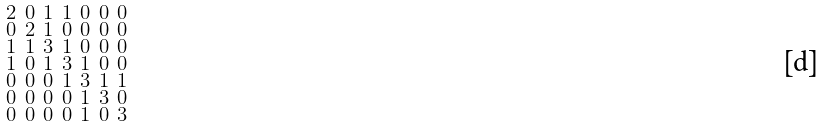<formula> <loc_0><loc_0><loc_500><loc_500>\begin{smallmatrix} 2 & 0 & 1 & 1 & 0 & 0 & 0 \\ 0 & 2 & 1 & 0 & 0 & 0 & 0 \\ 1 & 1 & 3 & 1 & 0 & 0 & 0 \\ 1 & 0 & 1 & 3 & 1 & 0 & 0 \\ 0 & 0 & 0 & 1 & 3 & 1 & 1 \\ 0 & 0 & 0 & 0 & 1 & 3 & 0 \\ 0 & 0 & 0 & 0 & 1 & 0 & 3 \end{smallmatrix}</formula> 